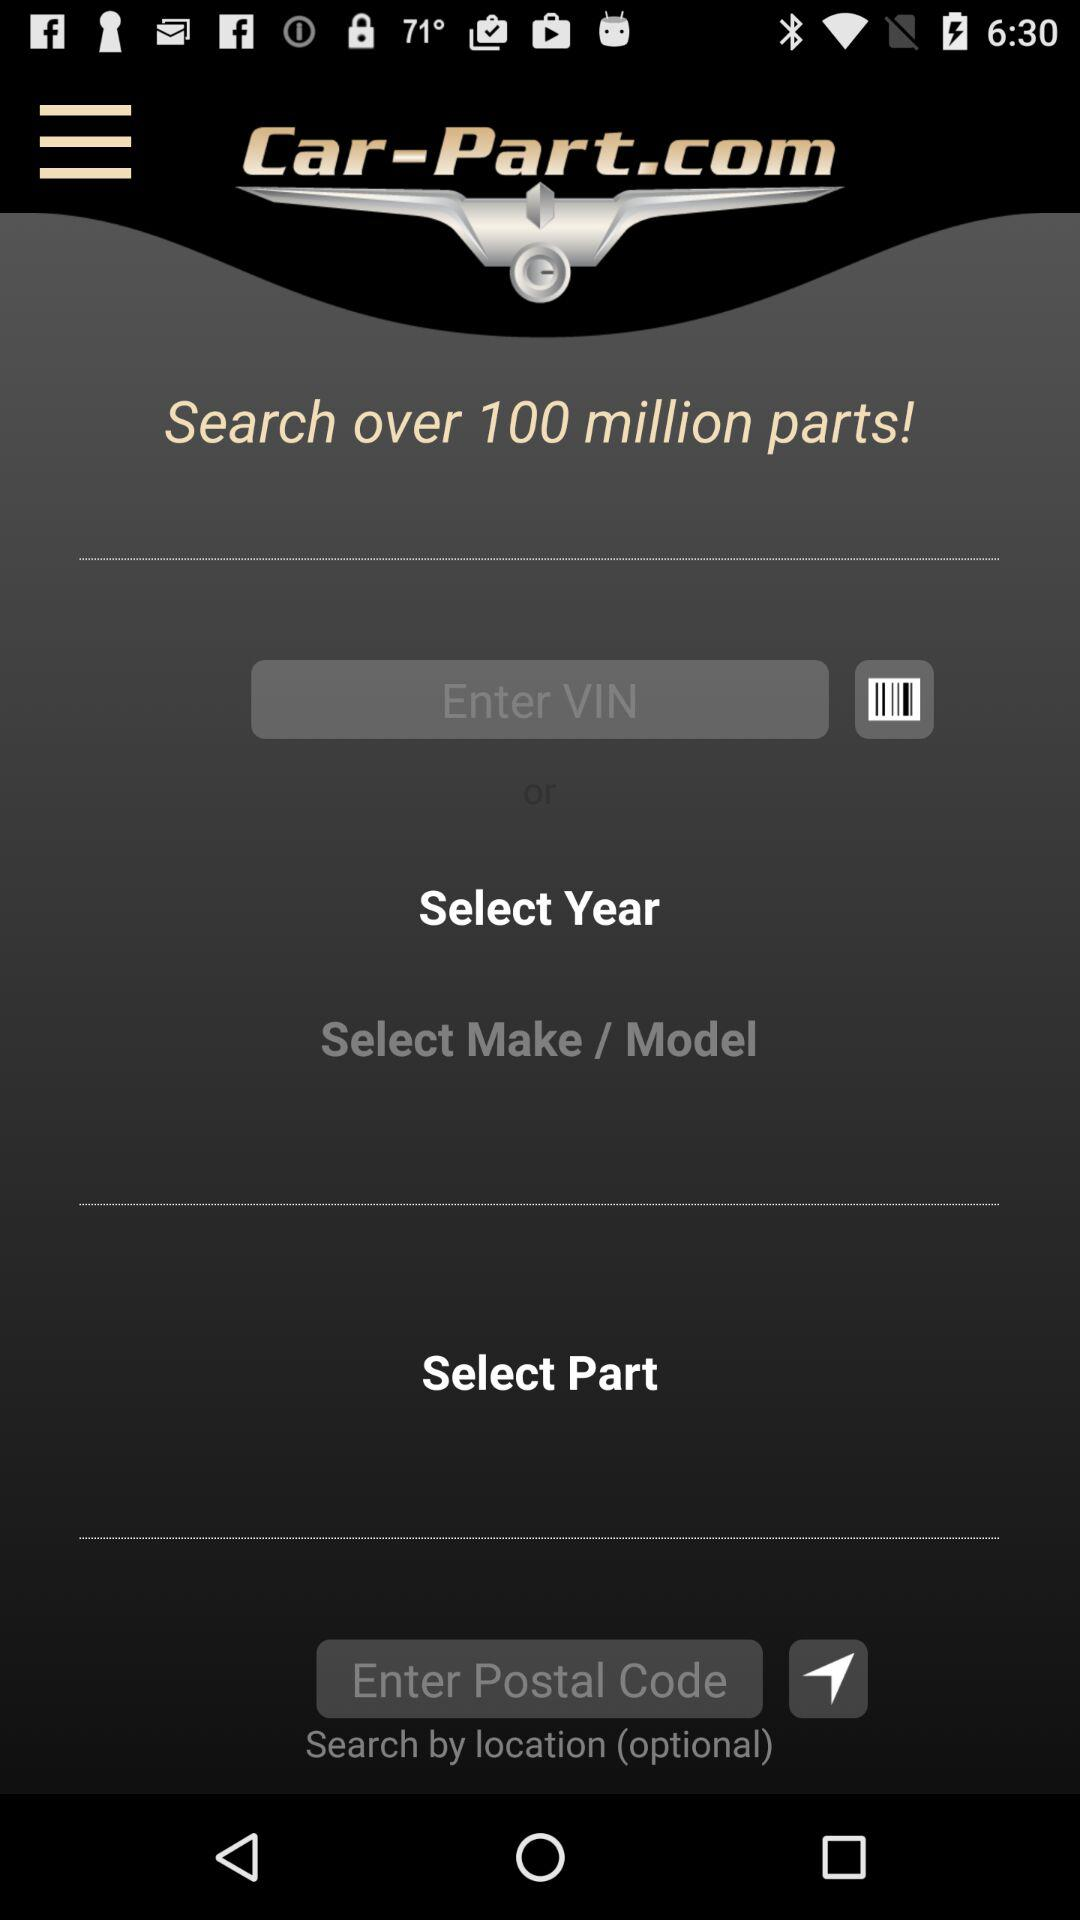How many parts can we search for? You can search for over 100 million parts. 